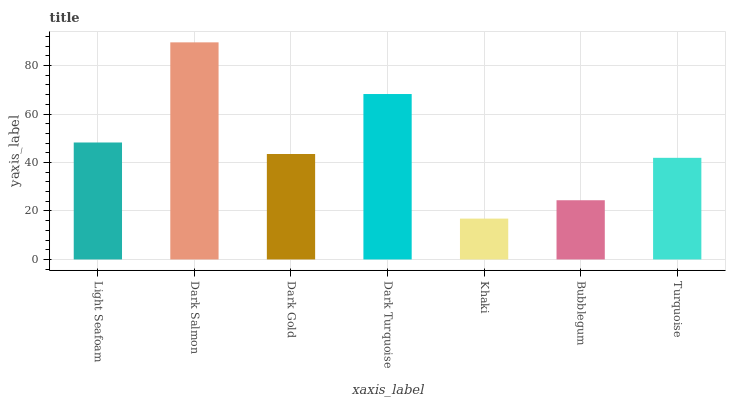Is Dark Gold the minimum?
Answer yes or no. No. Is Dark Gold the maximum?
Answer yes or no. No. Is Dark Salmon greater than Dark Gold?
Answer yes or no. Yes. Is Dark Gold less than Dark Salmon?
Answer yes or no. Yes. Is Dark Gold greater than Dark Salmon?
Answer yes or no. No. Is Dark Salmon less than Dark Gold?
Answer yes or no. No. Is Dark Gold the high median?
Answer yes or no. Yes. Is Dark Gold the low median?
Answer yes or no. Yes. Is Light Seafoam the high median?
Answer yes or no. No. Is Khaki the low median?
Answer yes or no. No. 